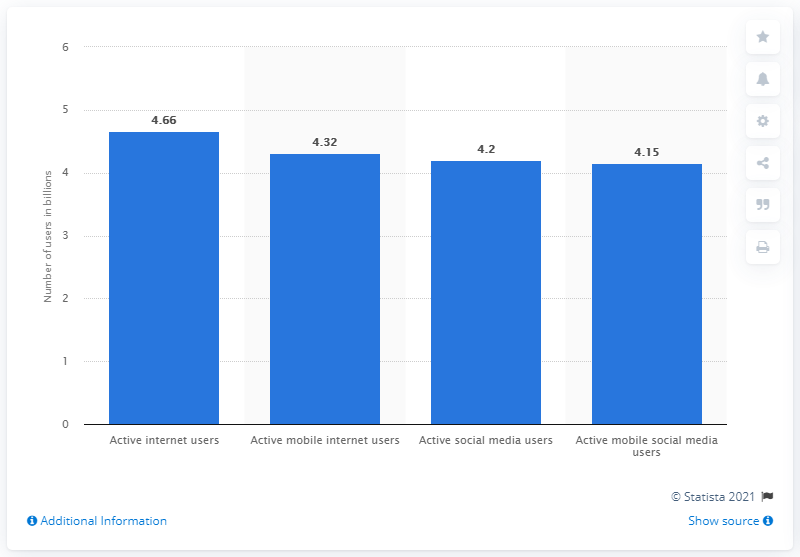List a handful of essential elements in this visual. As of January 2021, it is estimated that 4.66 billion people use the internet. 